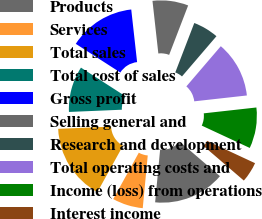Convert chart to OTSL. <chart><loc_0><loc_0><loc_500><loc_500><pie_chart><fcel>Products<fcel>Services<fcel>Total sales<fcel>Total cost of sales<fcel>Gross profit<fcel>Selling general and<fcel>Research and development<fcel>Total operating costs and<fcel>Income (loss) from operations<fcel>Interest income<nl><fcel>15.22%<fcel>6.52%<fcel>16.3%<fcel>9.78%<fcel>14.13%<fcel>7.61%<fcel>5.43%<fcel>11.96%<fcel>8.7%<fcel>4.35%<nl></chart> 